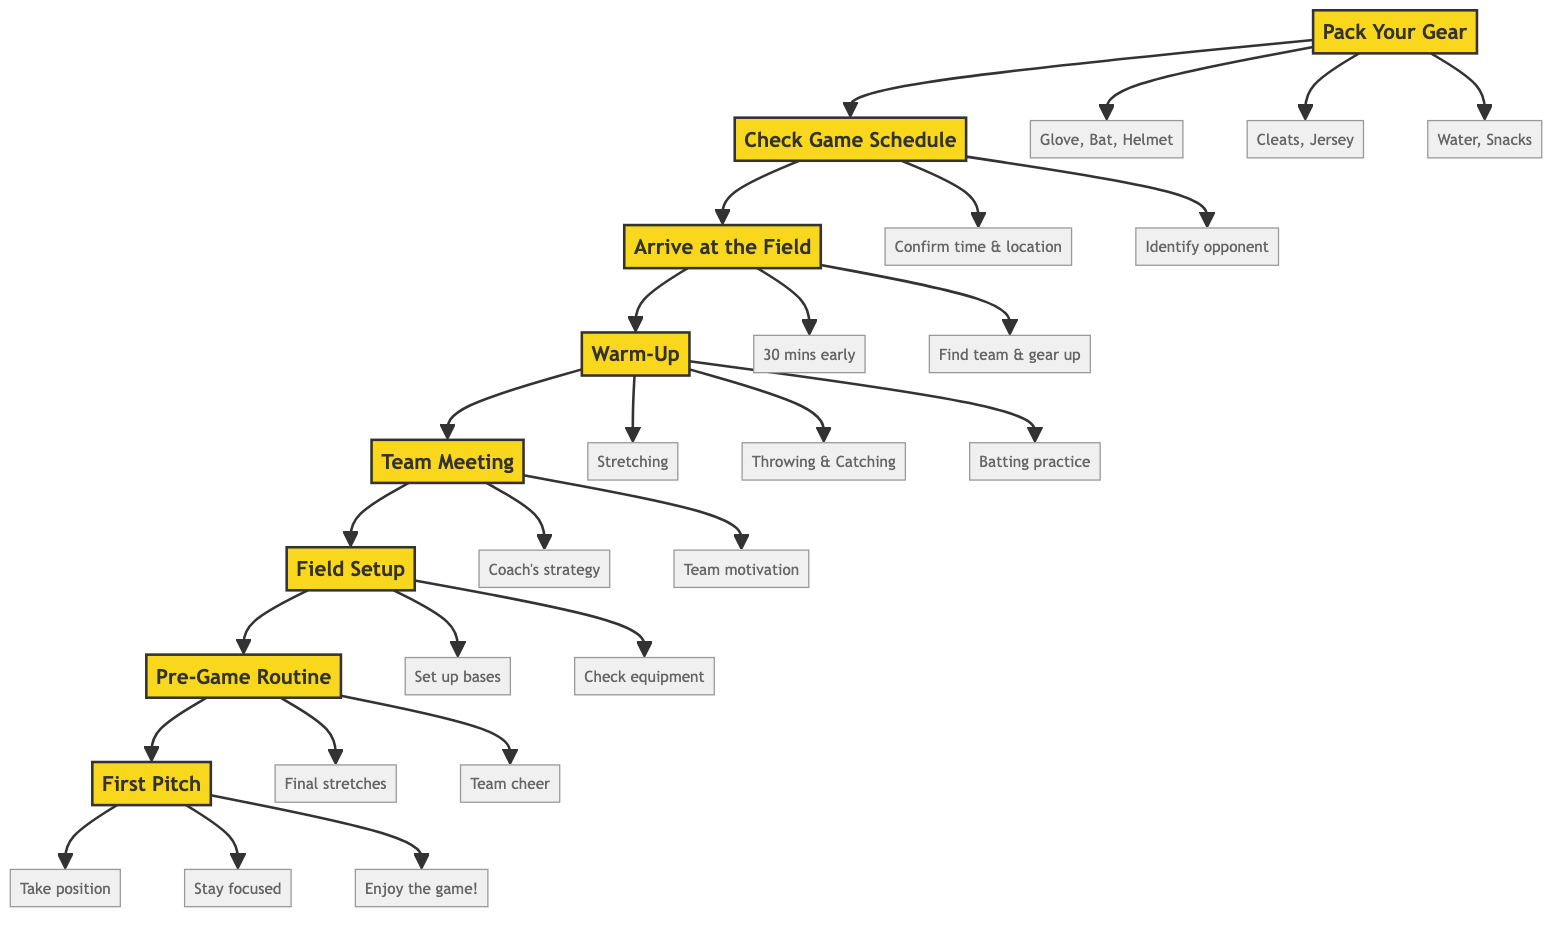What is the first step in preparing for a Little League game? The diagram starts with the first node, "Pack Your Gear," indicating that this is the initial step in the preparation process.
Answer: Pack Your Gear How many main steps are there in the diagram? By counting the nodes that represent each main step, there are a total of 8 steps in the flowchart.
Answer: 8 What are the details associated with the "Team Meeting" step? Looking at the "Team Meeting" node, it shows two details: "Listen to coach's strategy" and "Get motivated by teammates." These details illustrate the key actions taken during this step.
Answer: Listen to coach's strategy, Get motivated by teammates What should you do after warming up? The flowchart indicates that after the "Warm-Up" step, the next step is "Team Meeting." This shows the order of activities leading up to the game.
Answer: Team Meeting What are the last three actions before the first pitch? According to the flowchart, the last three actions before the "First Pitch" are "Final stretches," "Team cheer," and "Focus on the game," which are all part of the "Pre-Game Routine."
Answer: Final stretches, Team cheer, Focus on the game How do the steps connect from arriving at the field to the first pitch? The flowchart illustrates a direct connection from "Arrive at the Field" to "Warm-Up," then to "Team Meeting," followed by "Field Setup," "Pre-Game Routine," and finally leading to "First Pitch." This sequential flow indicates the order of preparations made.
Answer: Arrive at the Field → Warm-Up → Team Meeting → Field Setup → Pre-Game Routine → First Pitch What preparations are involved in "Field Setup"? In the "Field Setup" node, there are details listed: "Help set up bases," "Check equipment," and "Make sure the field is safe," which clarify what actions are taken during this step.
Answer: Help set up bases, Check equipment, Make sure the field is safe What do players need to pack according to the diagram? The diagram specifies several items that must be packed under "Pack Your Gear," including "Baseball glove," "Bat," "Helmet," "Cleats," "Jersey," "Water bottle," and "Snacks."
Answer: Baseball glove, Bat, Helmet, Cleats, Jersey, Water bottle, Snacks 